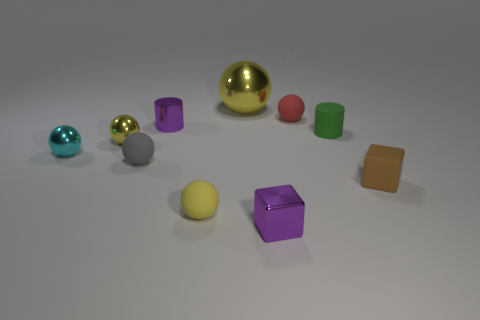Are the purple object that is behind the tiny gray rubber ball and the brown cube made of the same material?
Offer a terse response. No. Is there anything else that is the same size as the gray ball?
Keep it short and to the point. Yes. There is a big yellow metal object; are there any small gray balls behind it?
Your answer should be compact. No. What is the color of the small cylinder that is to the right of the small ball that is right of the small yellow sphere in front of the brown thing?
Offer a very short reply. Green. The red rubber thing that is the same size as the rubber cylinder is what shape?
Provide a succinct answer. Sphere. Are there more matte spheres than brown matte cubes?
Provide a short and direct response. Yes. Are there any small yellow spheres that are behind the cube that is right of the tiny green cylinder?
Offer a terse response. Yes. There is a big metal object that is the same shape as the tiny gray thing; what is its color?
Make the answer very short. Yellow. Is there anything else that has the same shape as the small red rubber object?
Offer a very short reply. Yes. There is a small cylinder that is made of the same material as the cyan object; what color is it?
Your answer should be compact. Purple. 